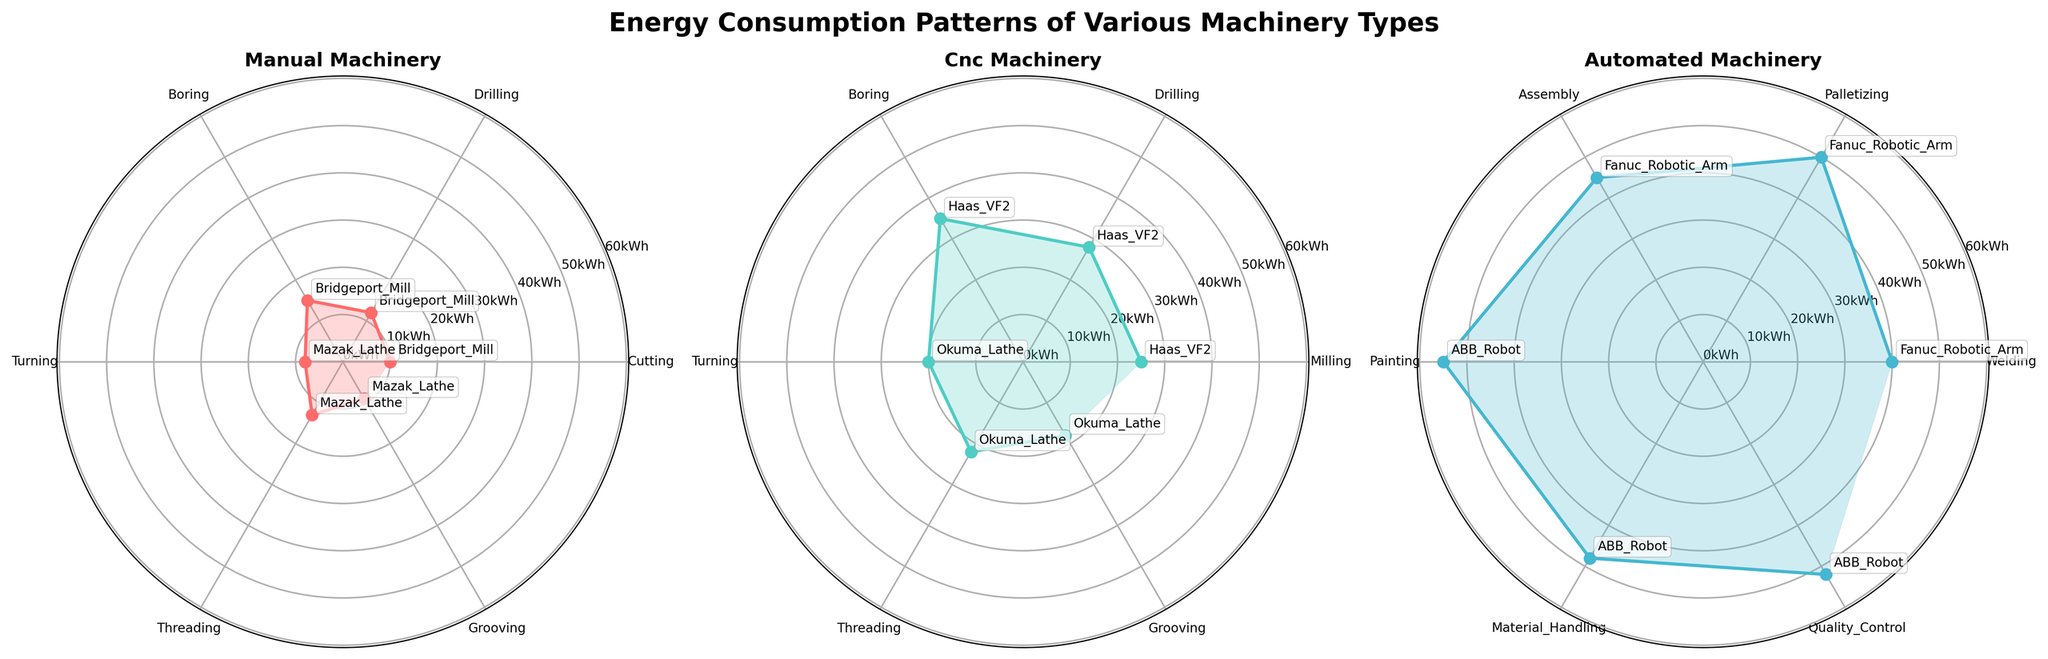What's the title of the plot? The title of the plot is written at the top of the figure in bold. It states the overall subject the figure is depicting.
Answer: Energy Consumption Patterns of Various Machinery Types Which category of machinery has the highest energy consumption for a single axis operation? To find this, we compare the highest energy consumption values from the three categories in the subplots. The highest value for manual machines is 15 kWh, for CNC is 35 kWh, and for automated is 55 kWh.
Answer: automated What is the average energy consumption for the manual machines across all axes? Sum the energy consumption values for all operations of manual machines, then divide by the number of operations. The values are 10, 12, 15, 8, 13, 9. The sum is 67 and there are 6 data points. The average is 67/6.
Answer: 11.17 kWh Which machine has the lowest energy consumption in the CNC category, and for which axis? Comparing the energy consumption values for all CNC machines, the lowest value is 18 kWh. The corresponding machine is Okuma Lathe, and the axis is Grooving.
Answer: Okuma Lathe, Grooving How does the energy consumption for Milling compare between a CNC machine and an automated machine? The energy consumption for Milling in CNC (Haas VF2) is 25 kWh, whereas automated machines (Fanuc Robotic Arm) do not have a Milling operation listed. Therefore, we only have 25 kWh for CNC.
Answer: CNC 25 kWh What is the difference in energy consumption between the highest and lowest axes for the automated machinery category? The highest energy consumption value for automated machinery is 55 kWh (Painting for ABB Robot), and the lowest is 40 kWh (Welding for Fanuc Robotic Arm). The difference is 55 - 40.
Answer: 15 kWh For the manual machines, which operation has the highest energy consumption and what is its value? In the manual machinery subplot, the highest energy value is 15 kWh for the Boring operation of Bridgeport Mill.
Answer: Boring, 15 kWh Compare the energy consumption of Drilling in manual and CNC machines. Which one consumes more energy, and by how much? For Drilling, manual (Bridgeport Mill) consumes 12 kWh and CNC (Haas VF2) consumes 28 kWh. The difference is 28 - 12.
Answer: CNC, 16 kWh What is the total energy consumption by Okuma Lathe across all operations? Add the energy consumption values for all operations of Okuma Lathe. The values are 20, 22, and 18 kWh. The sum is 20 + 22 + 18.
Answer: 60 kWh 